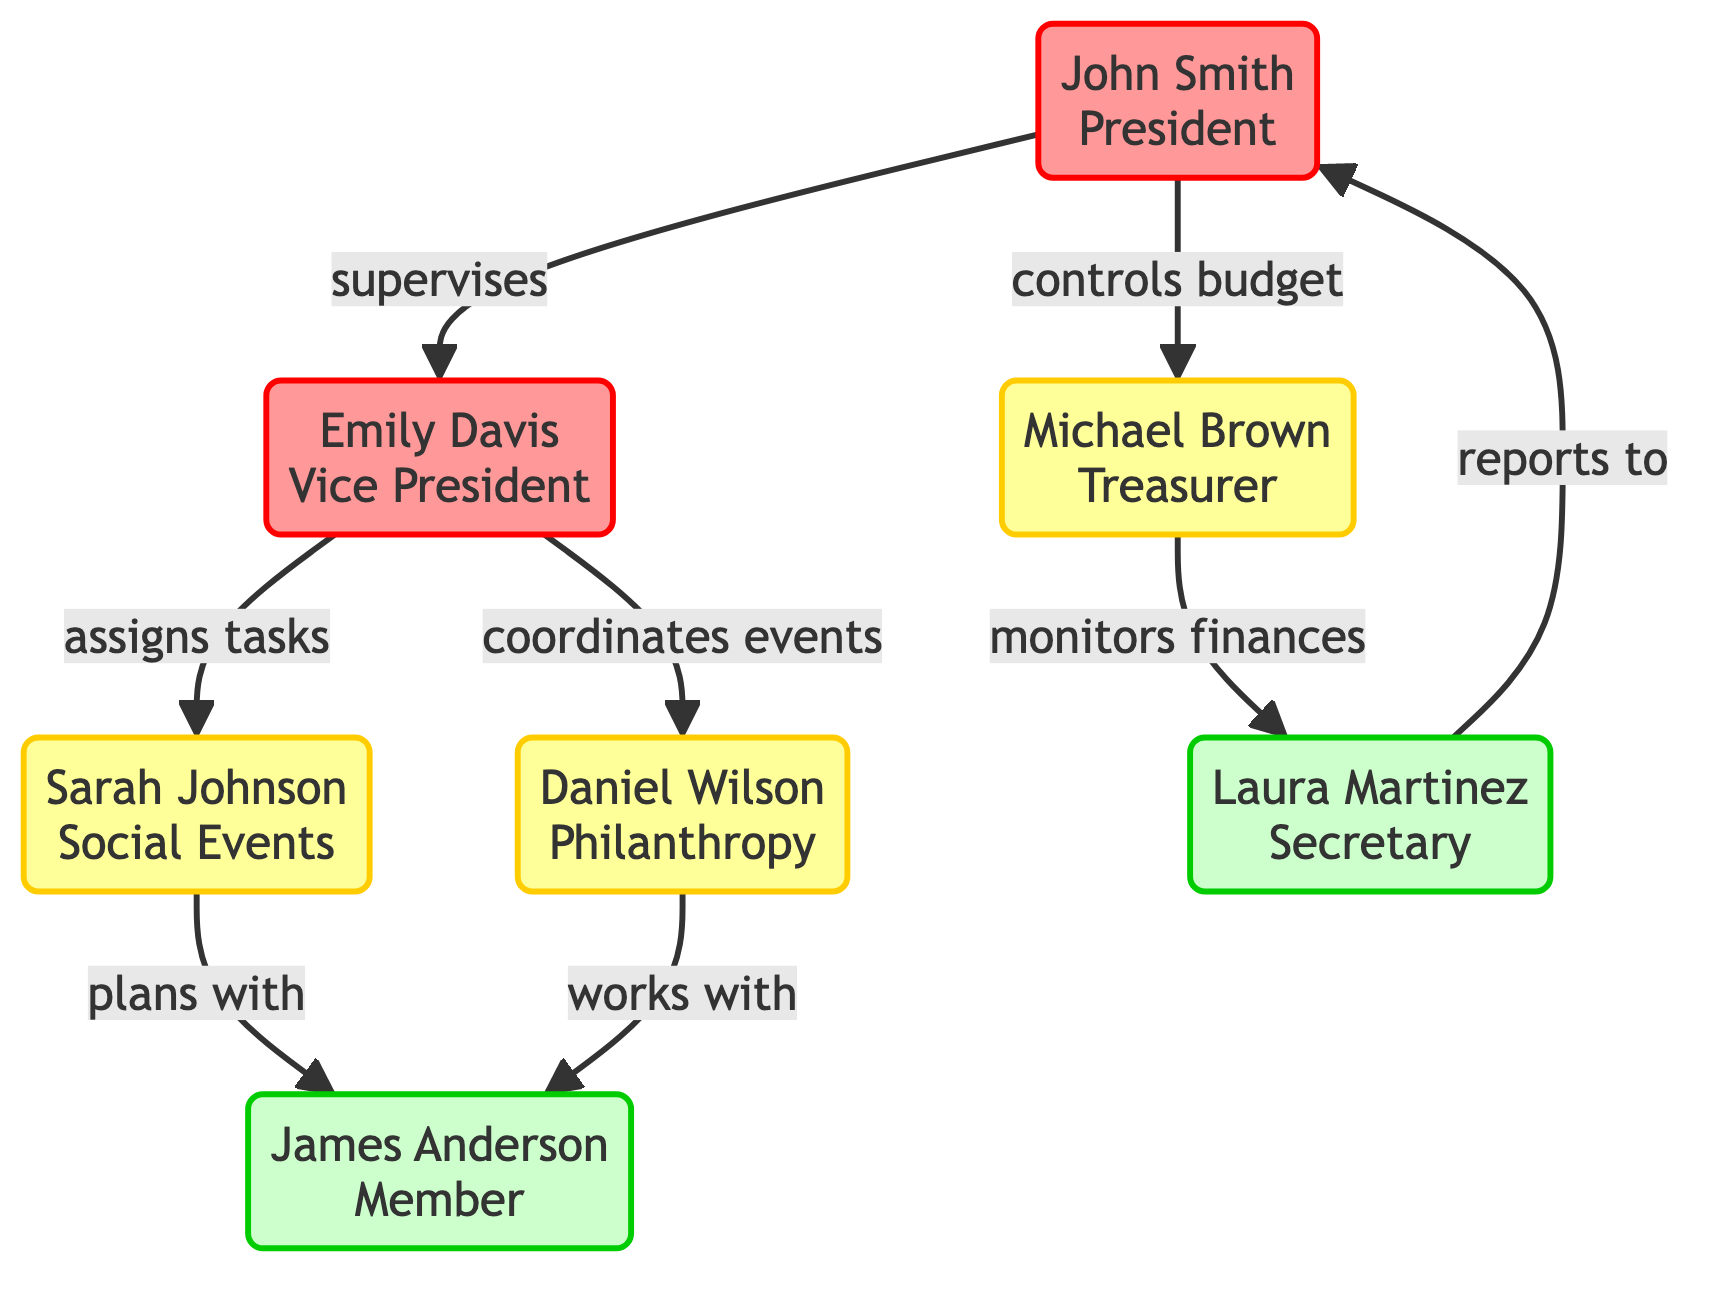What is the highest influence score? The highest influence score is represented by John Smith at the top of the diagram. His influence score is 0.95.
Answer: 0.95 How many members are there in the diagram? The total number of nodes (members) in the diagram is seven, as counted from nodes labeled from 1 to 7.
Answer: 7 Who is Michael Brown's supervisor? In the diagram, Michael Brown is supervised by John Smith, who is indicated by the directed edge leading from John Smith to Michael Brown.
Answer: John Smith Which member coordinates philanthropy events? The member who coordinates philanthropy events is Emily Davis, indicated by her connection with Daniel Wilson in the "coordinates philanthropy events" relationship.
Answer: Emily Davis How many edges are present in the diagram? The edges represent relationships between the members, and a count reveals there are eight directed edges shown connecting the various members.
Answer: 8 Who assigns tasks to Sarah Johnson? Sarah Johnson receives task assignments from Emily Davis, illustrated by the directed edge connecting these two nodes with the "assigns tasks" label.
Answer: Emily Davis Which role has the lowest influence score? The role with the lowest influence score is that of James Anderson, who has an influence score of 0.60, as represented in the diagram.
Answer: James Anderson What relationship exists between Laura Martinez and John Smith? Laura Martinez has a reporting relationship to John Smith, indicated by the directed edge that shows she reports meeting minutes to him.
Answer: reports minutes to What is the relationship between Sarah Johnson and James Anderson? The relationship is labeled "plans with", which is represented by the directed edge from Sarah Johnson to James Anderson in the diagram.
Answer: plans with 